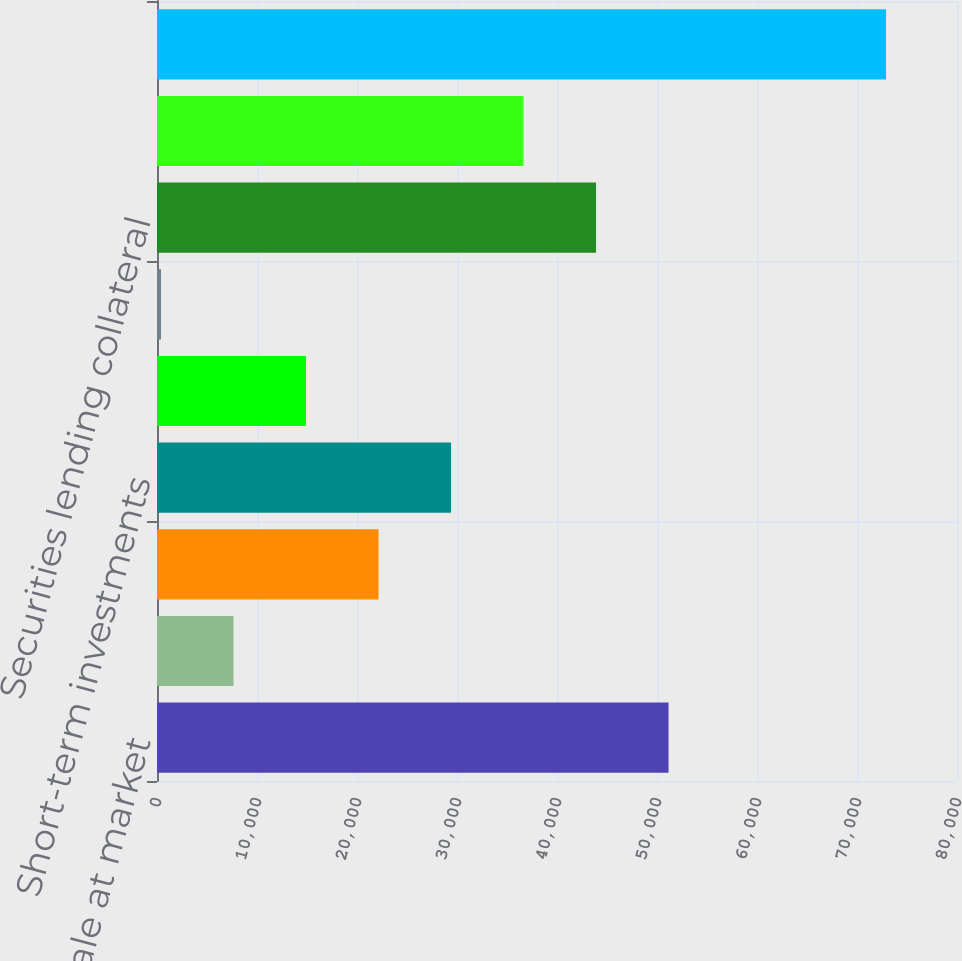<chart> <loc_0><loc_0><loc_500><loc_500><bar_chart><fcel>Available for sale at market<fcel>Common stocks at market value<fcel>Mortgage loans on real estate<fcel>Short-term investments<fcel>Real estate<fcel>Investment income due and<fcel>Securities lending collateral<fcel>Other invested assets<fcel>Total<nl><fcel>51154.1<fcel>7652.3<fcel>22152.9<fcel>29403.2<fcel>14902.6<fcel>402<fcel>43903.8<fcel>36653.5<fcel>72905<nl></chart> 